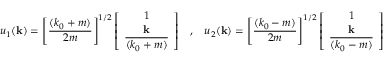Convert formula to latex. <formula><loc_0><loc_0><loc_500><loc_500>u _ { 1 } ( { k } ) = \left [ \frac { ( k _ { 0 } + m ) } { 2 m } \right ] ^ { 1 / 2 } \left [ \begin{array} { c } { 1 } \\ { k } \\ { { \overline { { { ( k _ { 0 } + m ) } } } } } \end{array} \right ] \, , \, u _ { 2 } ( { k } ) = \left [ \frac { ( k _ { 0 } - m ) } { 2 m } \right ] ^ { 1 / 2 } \left [ \begin{array} { c } { 1 } \\ { k } \\ { { \overline { { { ( k _ { 0 } - m ) } } } } } \end{array} \right ] \, .</formula> 